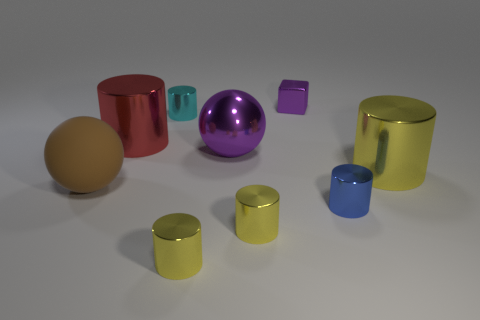Subtract all blue balls. How many yellow cylinders are left? 3 Subtract all blue shiny cylinders. How many cylinders are left? 5 Subtract all cyan cylinders. How many cylinders are left? 5 Add 1 tiny yellow metallic objects. How many objects exist? 10 Subtract all blue cylinders. Subtract all yellow blocks. How many cylinders are left? 5 Subtract all blocks. How many objects are left? 8 Add 3 big rubber spheres. How many big rubber spheres exist? 4 Subtract 1 cyan cylinders. How many objects are left? 8 Subtract all green rubber cylinders. Subtract all small blue cylinders. How many objects are left? 8 Add 7 large purple balls. How many large purple balls are left? 8 